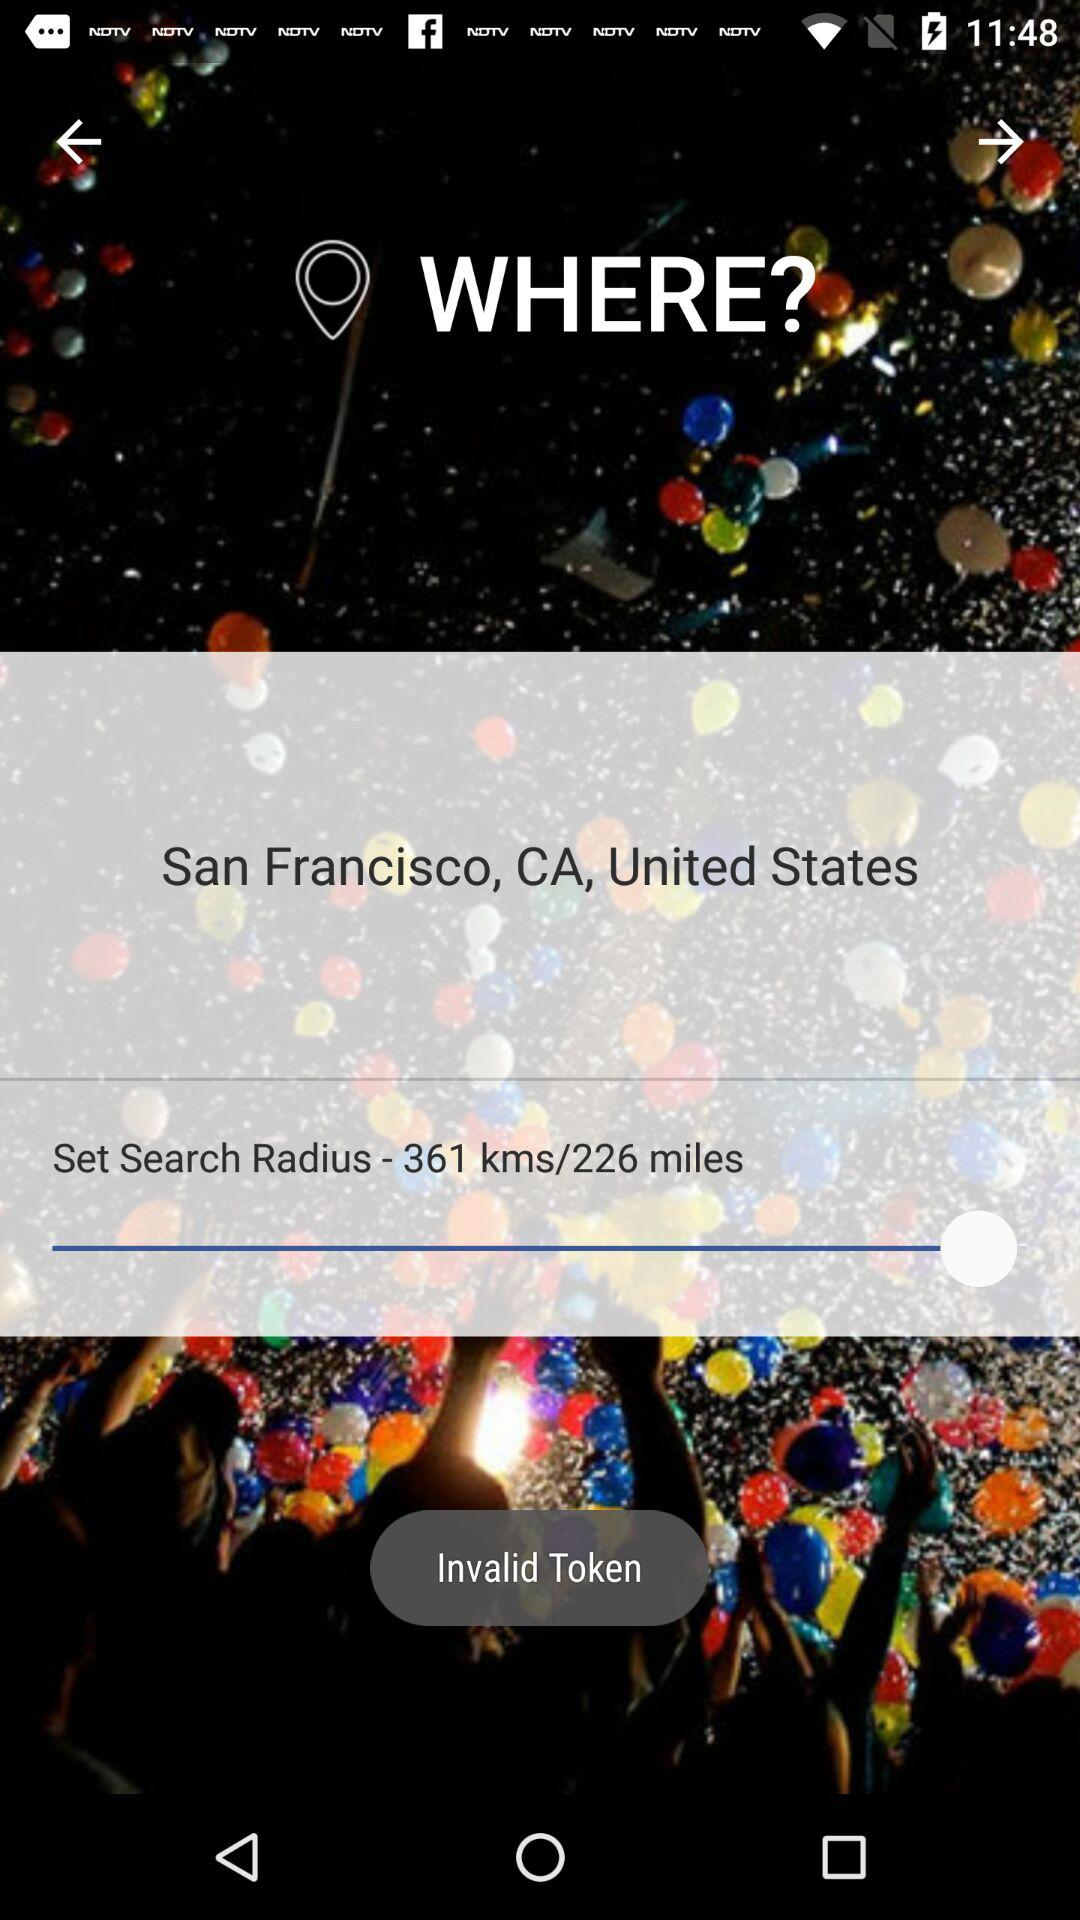What is the location? The location is San Francisco, CA, United States. 